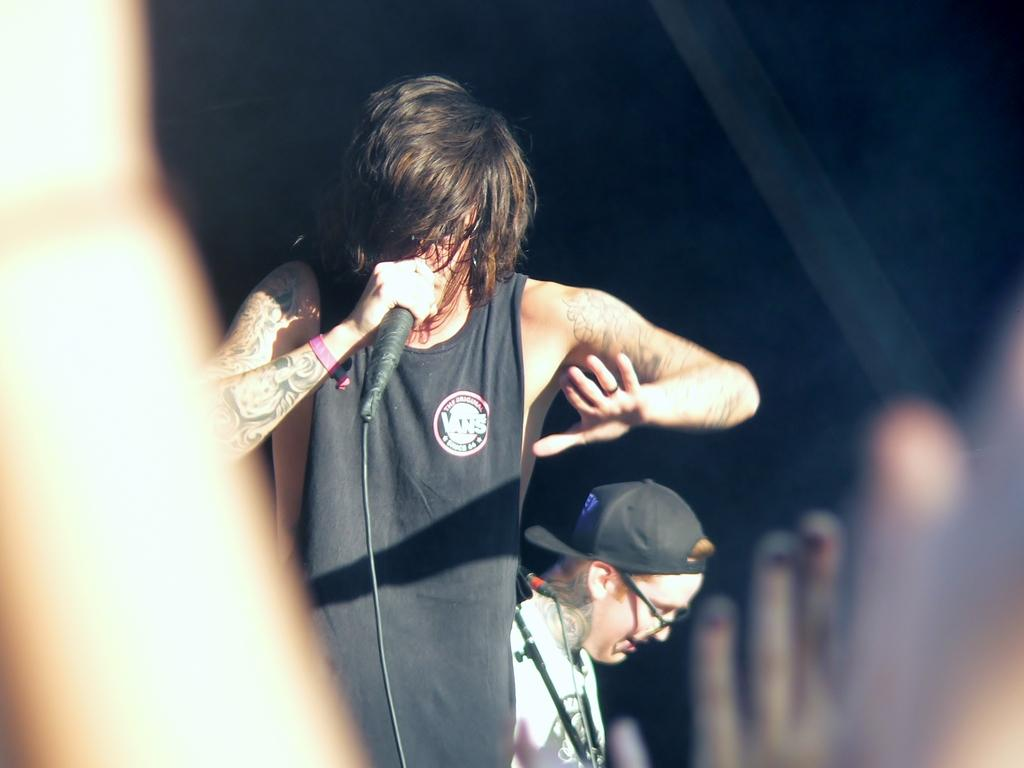What is the man in the image doing? The man is singing in the image. What is the man wearing in the image? The man is wearing a black color top in the image. Can you describe the other person in the image? The other person is wearing a black color cap in the image. What type of agreement is being discussed between the giants in the image? There are no giants present in the image, so there is no discussion about any agreements. 